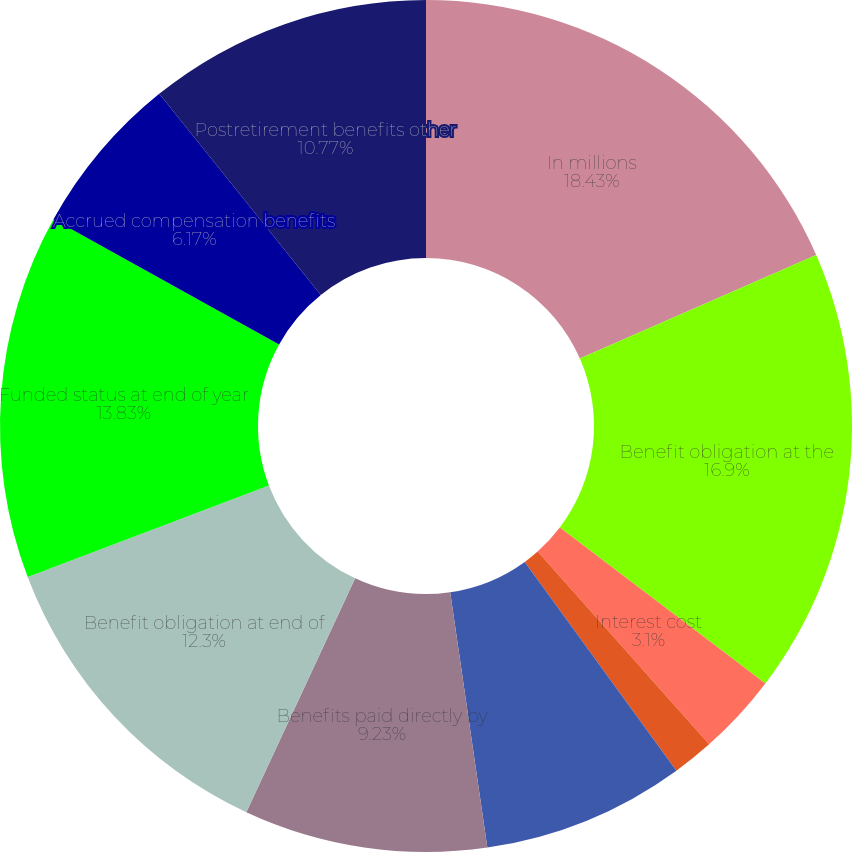<chart> <loc_0><loc_0><loc_500><loc_500><pie_chart><fcel>In millions<fcel>Benefit obligation at the<fcel>Interest cost<fcel>Plan participants'<fcel>Actuarial loss (gain)<fcel>Benefits paid directly by<fcel>Benefit obligation at end of<fcel>Funded status at end of year<fcel>Accrued compensation benefits<fcel>Postretirement benefits other<nl><fcel>18.43%<fcel>16.9%<fcel>3.1%<fcel>1.57%<fcel>7.7%<fcel>9.23%<fcel>12.3%<fcel>13.83%<fcel>6.17%<fcel>10.77%<nl></chart> 